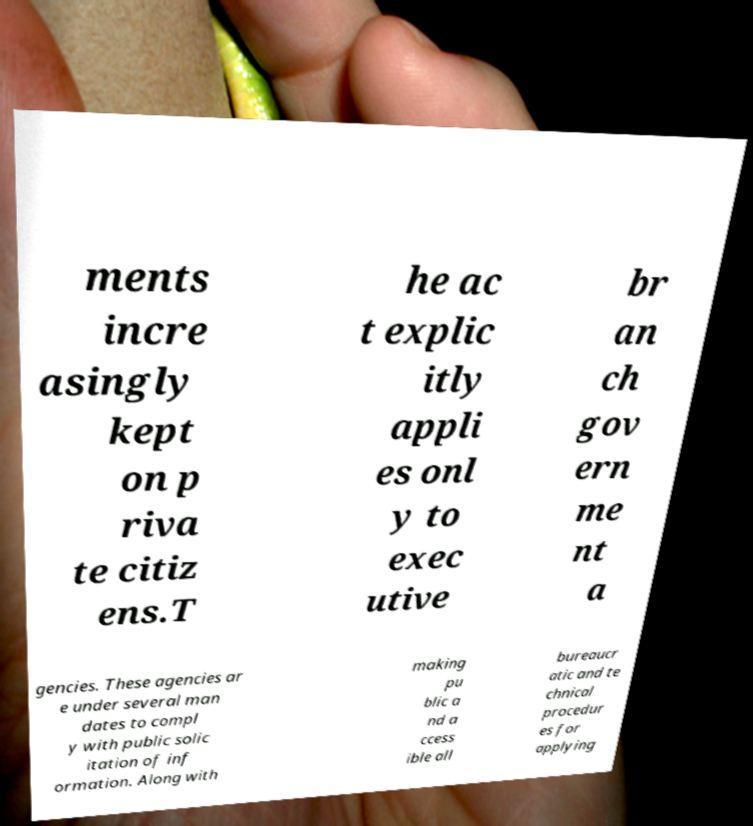Please identify and transcribe the text found in this image. ments incre asingly kept on p riva te citiz ens.T he ac t explic itly appli es onl y to exec utive br an ch gov ern me nt a gencies. These agencies ar e under several man dates to compl y with public solic itation of inf ormation. Along with making pu blic a nd a ccess ible all bureaucr atic and te chnical procedur es for applying 